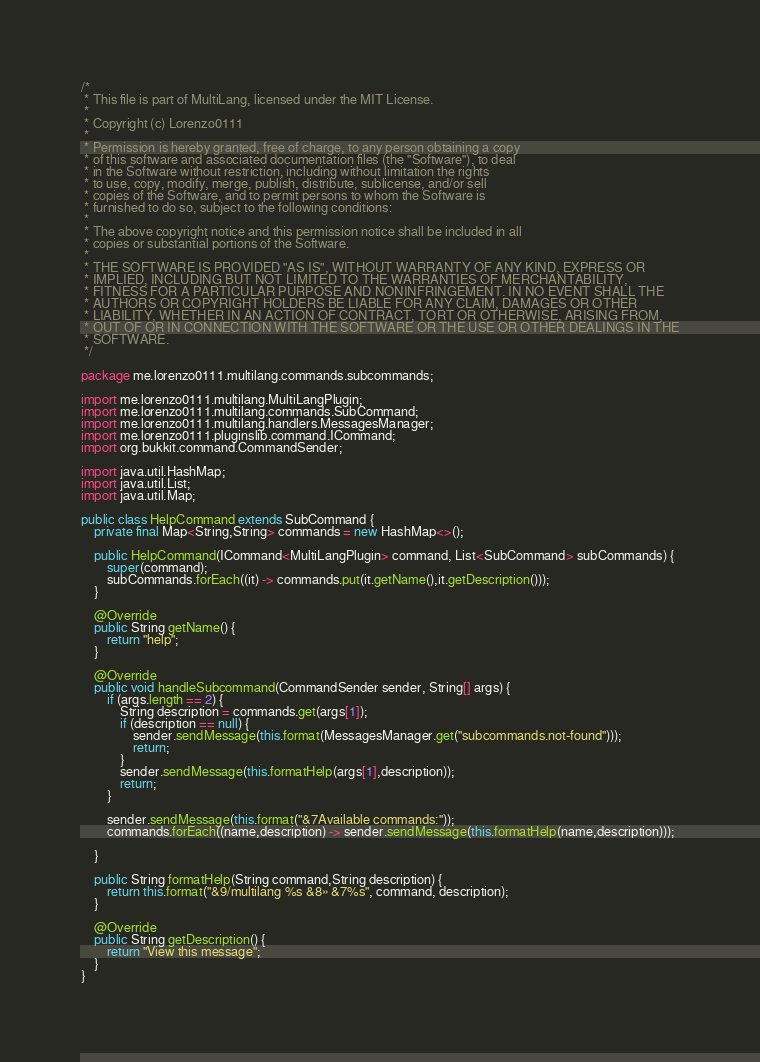<code> <loc_0><loc_0><loc_500><loc_500><_Java_>/*
 * This file is part of MultiLang, licensed under the MIT License.
 *
 * Copyright (c) Lorenzo0111
 *
 * Permission is hereby granted, free of charge, to any person obtaining a copy
 * of this software and associated documentation files (the "Software"), to deal
 * in the Software without restriction, including without limitation the rights
 * to use, copy, modify, merge, publish, distribute, sublicense, and/or sell
 * copies of the Software, and to permit persons to whom the Software is
 * furnished to do so, subject to the following conditions:
 *
 * The above copyright notice and this permission notice shall be included in all
 * copies or substantial portions of the Software.
 *
 * THE SOFTWARE IS PROVIDED "AS IS", WITHOUT WARRANTY OF ANY KIND, EXPRESS OR
 * IMPLIED, INCLUDING BUT NOT LIMITED TO THE WARRANTIES OF MERCHANTABILITY,
 * FITNESS FOR A PARTICULAR PURPOSE AND NONINFRINGEMENT. IN NO EVENT SHALL THE
 * AUTHORS OR COPYRIGHT HOLDERS BE LIABLE FOR ANY CLAIM, DAMAGES OR OTHER
 * LIABILITY, WHETHER IN AN ACTION OF CONTRACT, TORT OR OTHERWISE, ARISING FROM,
 * OUT OF OR IN CONNECTION WITH THE SOFTWARE OR THE USE OR OTHER DEALINGS IN THE
 * SOFTWARE.
 */

package me.lorenzo0111.multilang.commands.subcommands;

import me.lorenzo0111.multilang.MultiLangPlugin;
import me.lorenzo0111.multilang.commands.SubCommand;
import me.lorenzo0111.multilang.handlers.MessagesManager;
import me.lorenzo0111.pluginslib.command.ICommand;
import org.bukkit.command.CommandSender;

import java.util.HashMap;
import java.util.List;
import java.util.Map;

public class HelpCommand extends SubCommand {
    private final Map<String,String> commands = new HashMap<>();

    public HelpCommand(ICommand<MultiLangPlugin> command, List<SubCommand> subCommands) {
        super(command);
        subCommands.forEach((it) -> commands.put(it.getName(),it.getDescription()));
    }

    @Override
    public String getName() {
        return "help";
    }

    @Override
    public void handleSubcommand(CommandSender sender, String[] args) {
        if (args.length == 2) {
            String description = commands.get(args[1]);
            if (description == null) {
                sender.sendMessage(this.format(MessagesManager.get("subcommands.not-found")));
                return;
            }
            sender.sendMessage(this.formatHelp(args[1],description));
            return;
        }

        sender.sendMessage(this.format("&7Available commands:"));
        commands.forEach((name,description) -> sender.sendMessage(this.formatHelp(name,description)));

    }

    public String formatHelp(String command,String description) {
        return this.format("&9/multilang %s &8» &7%s", command, description);
    }

    @Override
    public String getDescription() {
        return "View this message";
    }
}
</code> 